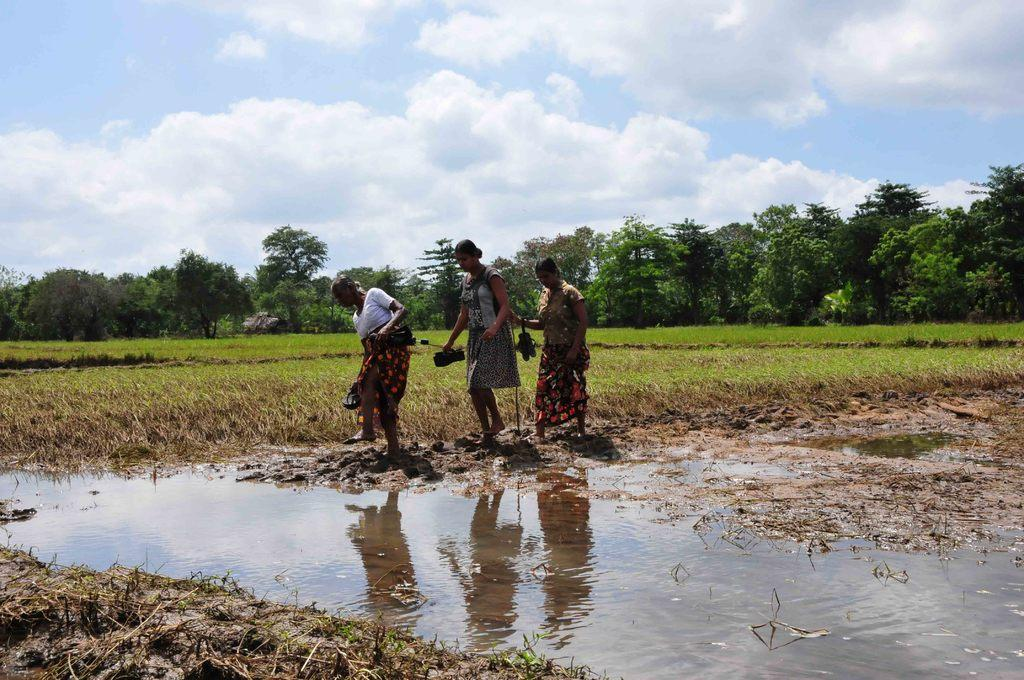How many women are present in the image? There are three women in the image. What are the women holding in their hands? The women are carrying footwear in their hands. What can be seen in the background of the image? There are trees and clouds in the sky in the background of the image. Is there any water visible in the image? Yes, there is water visible in the image. Can you tell me how many balls are being juggled by the women in the image? There are no balls being juggled by the women in the image; they are carrying footwear in their hands. What type of breath can be seen coming from the trees in the image? There is no breath visible in the image, as trees do not breathe like humans or animals. 